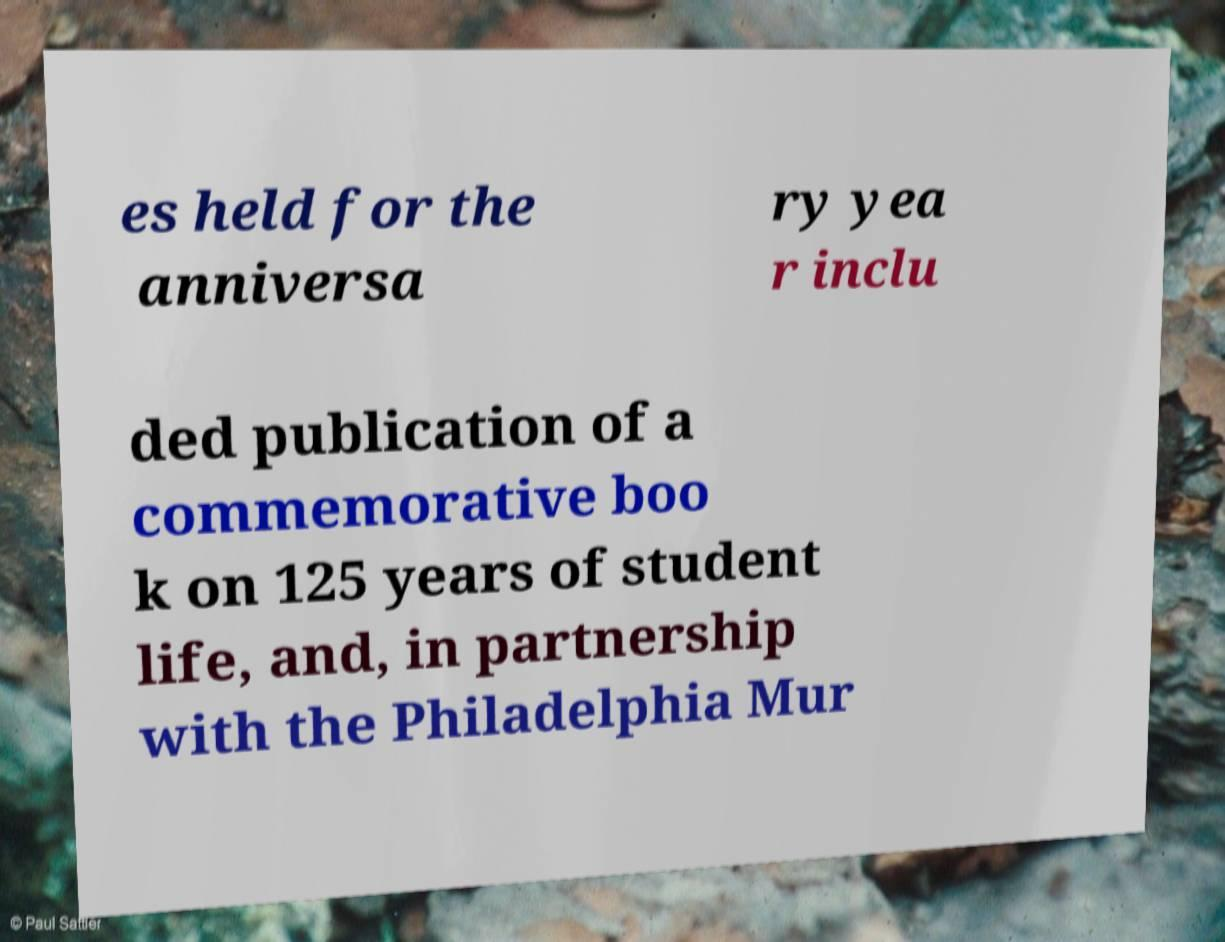For documentation purposes, I need the text within this image transcribed. Could you provide that? es held for the anniversa ry yea r inclu ded publication of a commemorative boo k on 125 years of student life, and, in partnership with the Philadelphia Mur 